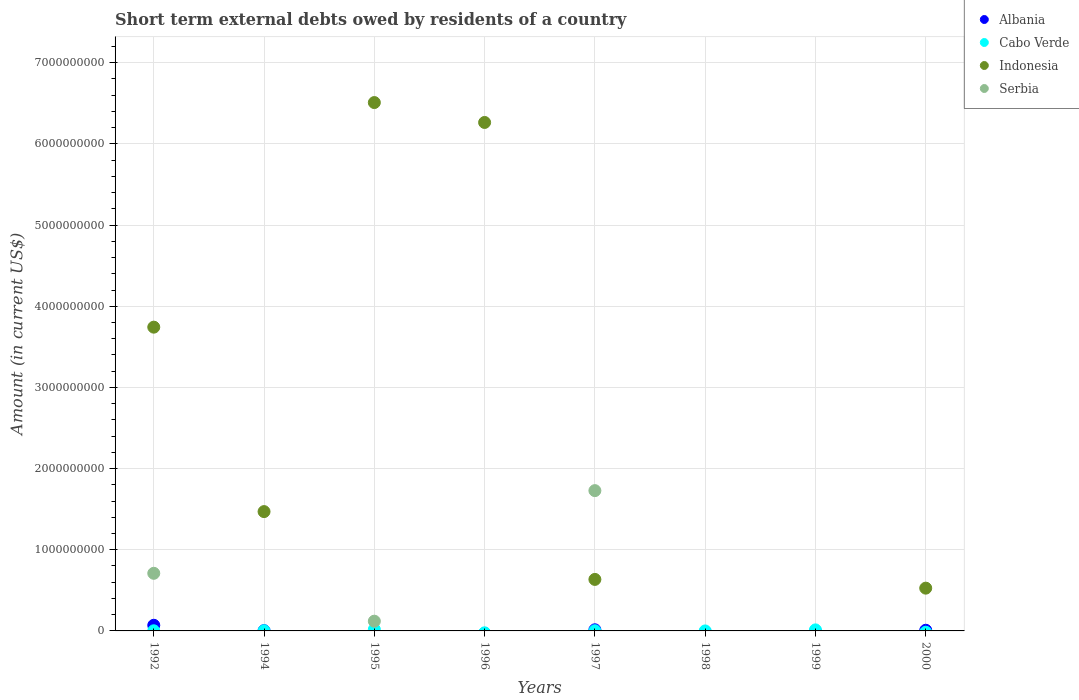How many different coloured dotlines are there?
Give a very brief answer. 4. What is the amount of short-term external debts owed by residents in Serbia in 1998?
Your response must be concise. 0. Across all years, what is the maximum amount of short-term external debts owed by residents in Cabo Verde?
Your response must be concise. 1.87e+07. What is the total amount of short-term external debts owed by residents in Serbia in the graph?
Your answer should be compact. 2.56e+09. What is the difference between the amount of short-term external debts owed by residents in Indonesia in 1996 and that in 1997?
Your answer should be very brief. 5.63e+09. What is the difference between the amount of short-term external debts owed by residents in Serbia in 1994 and the amount of short-term external debts owed by residents in Indonesia in 2000?
Provide a succinct answer. -5.27e+08. What is the average amount of short-term external debts owed by residents in Albania per year?
Offer a terse response. 1.19e+07. In the year 1994, what is the difference between the amount of short-term external debts owed by residents in Indonesia and amount of short-term external debts owed by residents in Cabo Verde?
Offer a terse response. 1.47e+09. What is the difference between the highest and the second highest amount of short-term external debts owed by residents in Albania?
Offer a very short reply. 5.57e+07. What is the difference between the highest and the lowest amount of short-term external debts owed by residents in Indonesia?
Keep it short and to the point. 6.51e+09. Is it the case that in every year, the sum of the amount of short-term external debts owed by residents in Cabo Verde and amount of short-term external debts owed by residents in Albania  is greater than the sum of amount of short-term external debts owed by residents in Serbia and amount of short-term external debts owed by residents in Indonesia?
Offer a very short reply. No. How many dotlines are there?
Your response must be concise. 4. How many years are there in the graph?
Give a very brief answer. 8. Are the values on the major ticks of Y-axis written in scientific E-notation?
Provide a short and direct response. No. Does the graph contain any zero values?
Make the answer very short. Yes. How many legend labels are there?
Offer a very short reply. 4. How are the legend labels stacked?
Provide a short and direct response. Vertical. What is the title of the graph?
Keep it short and to the point. Short term external debts owed by residents of a country. What is the label or title of the X-axis?
Keep it short and to the point. Years. What is the label or title of the Y-axis?
Your response must be concise. Amount (in current US$). What is the Amount (in current US$) of Albania in 1992?
Offer a terse response. 6.96e+07. What is the Amount (in current US$) in Cabo Verde in 1992?
Your answer should be compact. 1.60e+06. What is the Amount (in current US$) in Indonesia in 1992?
Your response must be concise. 3.74e+09. What is the Amount (in current US$) in Serbia in 1992?
Keep it short and to the point. 7.10e+08. What is the Amount (in current US$) in Albania in 1994?
Provide a succinct answer. 3.22e+06. What is the Amount (in current US$) of Cabo Verde in 1994?
Provide a succinct answer. 2.00e+06. What is the Amount (in current US$) in Indonesia in 1994?
Give a very brief answer. 1.47e+09. What is the Amount (in current US$) of Albania in 1995?
Provide a succinct answer. 0. What is the Amount (in current US$) in Cabo Verde in 1995?
Provide a short and direct response. 1.87e+07. What is the Amount (in current US$) in Indonesia in 1995?
Ensure brevity in your answer.  6.51e+09. What is the Amount (in current US$) in Serbia in 1995?
Offer a terse response. 1.20e+08. What is the Amount (in current US$) of Albania in 1996?
Offer a terse response. 0. What is the Amount (in current US$) of Cabo Verde in 1996?
Your response must be concise. 0. What is the Amount (in current US$) of Indonesia in 1996?
Provide a short and direct response. 6.26e+09. What is the Amount (in current US$) of Serbia in 1996?
Provide a short and direct response. 0. What is the Amount (in current US$) in Albania in 1997?
Keep it short and to the point. 1.39e+07. What is the Amount (in current US$) in Cabo Verde in 1997?
Provide a succinct answer. 1.96e+06. What is the Amount (in current US$) in Indonesia in 1997?
Your answer should be very brief. 6.35e+08. What is the Amount (in current US$) in Serbia in 1997?
Your answer should be compact. 1.73e+09. What is the Amount (in current US$) of Cabo Verde in 1998?
Ensure brevity in your answer.  0. What is the Amount (in current US$) in Albania in 1999?
Ensure brevity in your answer.  0. What is the Amount (in current US$) of Cabo Verde in 1999?
Keep it short and to the point. 1.28e+07. What is the Amount (in current US$) of Serbia in 1999?
Your answer should be compact. 0. What is the Amount (in current US$) of Albania in 2000?
Your response must be concise. 8.19e+06. What is the Amount (in current US$) in Indonesia in 2000?
Offer a terse response. 5.27e+08. What is the Amount (in current US$) in Serbia in 2000?
Provide a short and direct response. 0. Across all years, what is the maximum Amount (in current US$) of Albania?
Give a very brief answer. 6.96e+07. Across all years, what is the maximum Amount (in current US$) in Cabo Verde?
Your response must be concise. 1.87e+07. Across all years, what is the maximum Amount (in current US$) of Indonesia?
Give a very brief answer. 6.51e+09. Across all years, what is the maximum Amount (in current US$) in Serbia?
Your answer should be very brief. 1.73e+09. Across all years, what is the minimum Amount (in current US$) in Indonesia?
Keep it short and to the point. 0. Across all years, what is the minimum Amount (in current US$) in Serbia?
Give a very brief answer. 0. What is the total Amount (in current US$) in Albania in the graph?
Provide a short and direct response. 9.49e+07. What is the total Amount (in current US$) of Cabo Verde in the graph?
Offer a terse response. 3.70e+07. What is the total Amount (in current US$) of Indonesia in the graph?
Offer a terse response. 1.91e+1. What is the total Amount (in current US$) in Serbia in the graph?
Provide a short and direct response. 2.56e+09. What is the difference between the Amount (in current US$) in Albania in 1992 and that in 1994?
Your answer should be very brief. 6.64e+07. What is the difference between the Amount (in current US$) in Cabo Verde in 1992 and that in 1994?
Offer a terse response. -4.00e+05. What is the difference between the Amount (in current US$) of Indonesia in 1992 and that in 1994?
Keep it short and to the point. 2.27e+09. What is the difference between the Amount (in current US$) in Cabo Verde in 1992 and that in 1995?
Give a very brief answer. -1.71e+07. What is the difference between the Amount (in current US$) of Indonesia in 1992 and that in 1995?
Your answer should be compact. -2.77e+09. What is the difference between the Amount (in current US$) in Serbia in 1992 and that in 1995?
Your response must be concise. 5.90e+08. What is the difference between the Amount (in current US$) of Indonesia in 1992 and that in 1996?
Provide a short and direct response. -2.52e+09. What is the difference between the Amount (in current US$) in Albania in 1992 and that in 1997?
Give a very brief answer. 5.57e+07. What is the difference between the Amount (in current US$) of Cabo Verde in 1992 and that in 1997?
Keep it short and to the point. -3.60e+05. What is the difference between the Amount (in current US$) in Indonesia in 1992 and that in 1997?
Offer a terse response. 3.11e+09. What is the difference between the Amount (in current US$) in Serbia in 1992 and that in 1997?
Provide a succinct answer. -1.02e+09. What is the difference between the Amount (in current US$) in Cabo Verde in 1992 and that in 1999?
Offer a terse response. -1.12e+07. What is the difference between the Amount (in current US$) in Albania in 1992 and that in 2000?
Your answer should be very brief. 6.14e+07. What is the difference between the Amount (in current US$) of Indonesia in 1992 and that in 2000?
Give a very brief answer. 3.22e+09. What is the difference between the Amount (in current US$) of Cabo Verde in 1994 and that in 1995?
Provide a short and direct response. -1.67e+07. What is the difference between the Amount (in current US$) of Indonesia in 1994 and that in 1995?
Provide a succinct answer. -5.04e+09. What is the difference between the Amount (in current US$) of Indonesia in 1994 and that in 1996?
Offer a terse response. -4.79e+09. What is the difference between the Amount (in current US$) in Albania in 1994 and that in 1997?
Make the answer very short. -1.07e+07. What is the difference between the Amount (in current US$) in Cabo Verde in 1994 and that in 1997?
Provide a short and direct response. 4.00e+04. What is the difference between the Amount (in current US$) of Indonesia in 1994 and that in 1997?
Give a very brief answer. 8.35e+08. What is the difference between the Amount (in current US$) in Cabo Verde in 1994 and that in 1999?
Your response must be concise. -1.08e+07. What is the difference between the Amount (in current US$) of Albania in 1994 and that in 2000?
Give a very brief answer. -4.97e+06. What is the difference between the Amount (in current US$) in Indonesia in 1994 and that in 2000?
Provide a short and direct response. 9.43e+08. What is the difference between the Amount (in current US$) in Indonesia in 1995 and that in 1996?
Give a very brief answer. 2.45e+08. What is the difference between the Amount (in current US$) in Cabo Verde in 1995 and that in 1997?
Make the answer very short. 1.67e+07. What is the difference between the Amount (in current US$) in Indonesia in 1995 and that in 1997?
Give a very brief answer. 5.87e+09. What is the difference between the Amount (in current US$) in Serbia in 1995 and that in 1997?
Make the answer very short. -1.61e+09. What is the difference between the Amount (in current US$) of Cabo Verde in 1995 and that in 1999?
Offer a very short reply. 5.88e+06. What is the difference between the Amount (in current US$) in Indonesia in 1995 and that in 2000?
Provide a succinct answer. 5.98e+09. What is the difference between the Amount (in current US$) of Indonesia in 1996 and that in 1997?
Provide a short and direct response. 5.63e+09. What is the difference between the Amount (in current US$) of Indonesia in 1996 and that in 2000?
Keep it short and to the point. 5.74e+09. What is the difference between the Amount (in current US$) in Cabo Verde in 1997 and that in 1999?
Give a very brief answer. -1.08e+07. What is the difference between the Amount (in current US$) of Albania in 1997 and that in 2000?
Make the answer very short. 5.74e+06. What is the difference between the Amount (in current US$) in Indonesia in 1997 and that in 2000?
Offer a very short reply. 1.08e+08. What is the difference between the Amount (in current US$) of Albania in 1992 and the Amount (in current US$) of Cabo Verde in 1994?
Keep it short and to the point. 6.76e+07. What is the difference between the Amount (in current US$) of Albania in 1992 and the Amount (in current US$) of Indonesia in 1994?
Ensure brevity in your answer.  -1.40e+09. What is the difference between the Amount (in current US$) of Cabo Verde in 1992 and the Amount (in current US$) of Indonesia in 1994?
Provide a succinct answer. -1.47e+09. What is the difference between the Amount (in current US$) of Albania in 1992 and the Amount (in current US$) of Cabo Verde in 1995?
Ensure brevity in your answer.  5.09e+07. What is the difference between the Amount (in current US$) of Albania in 1992 and the Amount (in current US$) of Indonesia in 1995?
Offer a very short reply. -6.44e+09. What is the difference between the Amount (in current US$) of Albania in 1992 and the Amount (in current US$) of Serbia in 1995?
Your response must be concise. -5.03e+07. What is the difference between the Amount (in current US$) in Cabo Verde in 1992 and the Amount (in current US$) in Indonesia in 1995?
Make the answer very short. -6.51e+09. What is the difference between the Amount (in current US$) of Cabo Verde in 1992 and the Amount (in current US$) of Serbia in 1995?
Give a very brief answer. -1.18e+08. What is the difference between the Amount (in current US$) in Indonesia in 1992 and the Amount (in current US$) in Serbia in 1995?
Your response must be concise. 3.62e+09. What is the difference between the Amount (in current US$) in Albania in 1992 and the Amount (in current US$) in Indonesia in 1996?
Your answer should be very brief. -6.19e+09. What is the difference between the Amount (in current US$) of Cabo Verde in 1992 and the Amount (in current US$) of Indonesia in 1996?
Ensure brevity in your answer.  -6.26e+09. What is the difference between the Amount (in current US$) in Albania in 1992 and the Amount (in current US$) in Cabo Verde in 1997?
Offer a terse response. 6.76e+07. What is the difference between the Amount (in current US$) of Albania in 1992 and the Amount (in current US$) of Indonesia in 1997?
Offer a terse response. -5.65e+08. What is the difference between the Amount (in current US$) in Albania in 1992 and the Amount (in current US$) in Serbia in 1997?
Give a very brief answer. -1.66e+09. What is the difference between the Amount (in current US$) in Cabo Verde in 1992 and the Amount (in current US$) in Indonesia in 1997?
Give a very brief answer. -6.33e+08. What is the difference between the Amount (in current US$) in Cabo Verde in 1992 and the Amount (in current US$) in Serbia in 1997?
Make the answer very short. -1.73e+09. What is the difference between the Amount (in current US$) of Indonesia in 1992 and the Amount (in current US$) of Serbia in 1997?
Keep it short and to the point. 2.01e+09. What is the difference between the Amount (in current US$) in Albania in 1992 and the Amount (in current US$) in Cabo Verde in 1999?
Provide a succinct answer. 5.68e+07. What is the difference between the Amount (in current US$) in Albania in 1992 and the Amount (in current US$) in Indonesia in 2000?
Offer a very short reply. -4.57e+08. What is the difference between the Amount (in current US$) of Cabo Verde in 1992 and the Amount (in current US$) of Indonesia in 2000?
Your response must be concise. -5.25e+08. What is the difference between the Amount (in current US$) of Albania in 1994 and the Amount (in current US$) of Cabo Verde in 1995?
Your response must be concise. -1.54e+07. What is the difference between the Amount (in current US$) in Albania in 1994 and the Amount (in current US$) in Indonesia in 1995?
Your response must be concise. -6.51e+09. What is the difference between the Amount (in current US$) of Albania in 1994 and the Amount (in current US$) of Serbia in 1995?
Offer a very short reply. -1.17e+08. What is the difference between the Amount (in current US$) in Cabo Verde in 1994 and the Amount (in current US$) in Indonesia in 1995?
Your response must be concise. -6.51e+09. What is the difference between the Amount (in current US$) of Cabo Verde in 1994 and the Amount (in current US$) of Serbia in 1995?
Your answer should be compact. -1.18e+08. What is the difference between the Amount (in current US$) in Indonesia in 1994 and the Amount (in current US$) in Serbia in 1995?
Provide a short and direct response. 1.35e+09. What is the difference between the Amount (in current US$) of Albania in 1994 and the Amount (in current US$) of Indonesia in 1996?
Offer a terse response. -6.26e+09. What is the difference between the Amount (in current US$) in Cabo Verde in 1994 and the Amount (in current US$) in Indonesia in 1996?
Keep it short and to the point. -6.26e+09. What is the difference between the Amount (in current US$) in Albania in 1994 and the Amount (in current US$) in Cabo Verde in 1997?
Offer a very short reply. 1.26e+06. What is the difference between the Amount (in current US$) in Albania in 1994 and the Amount (in current US$) in Indonesia in 1997?
Make the answer very short. -6.31e+08. What is the difference between the Amount (in current US$) in Albania in 1994 and the Amount (in current US$) in Serbia in 1997?
Offer a very short reply. -1.73e+09. What is the difference between the Amount (in current US$) of Cabo Verde in 1994 and the Amount (in current US$) of Indonesia in 1997?
Provide a succinct answer. -6.33e+08. What is the difference between the Amount (in current US$) in Cabo Verde in 1994 and the Amount (in current US$) in Serbia in 1997?
Make the answer very short. -1.73e+09. What is the difference between the Amount (in current US$) in Indonesia in 1994 and the Amount (in current US$) in Serbia in 1997?
Your response must be concise. -2.58e+08. What is the difference between the Amount (in current US$) of Albania in 1994 and the Amount (in current US$) of Cabo Verde in 1999?
Provide a succinct answer. -9.56e+06. What is the difference between the Amount (in current US$) in Albania in 1994 and the Amount (in current US$) in Indonesia in 2000?
Your answer should be very brief. -5.24e+08. What is the difference between the Amount (in current US$) in Cabo Verde in 1994 and the Amount (in current US$) in Indonesia in 2000?
Provide a succinct answer. -5.25e+08. What is the difference between the Amount (in current US$) in Cabo Verde in 1995 and the Amount (in current US$) in Indonesia in 1996?
Provide a short and direct response. -6.25e+09. What is the difference between the Amount (in current US$) in Cabo Verde in 1995 and the Amount (in current US$) in Indonesia in 1997?
Provide a short and direct response. -6.16e+08. What is the difference between the Amount (in current US$) of Cabo Verde in 1995 and the Amount (in current US$) of Serbia in 1997?
Provide a succinct answer. -1.71e+09. What is the difference between the Amount (in current US$) of Indonesia in 1995 and the Amount (in current US$) of Serbia in 1997?
Offer a very short reply. 4.78e+09. What is the difference between the Amount (in current US$) of Cabo Verde in 1995 and the Amount (in current US$) of Indonesia in 2000?
Offer a terse response. -5.08e+08. What is the difference between the Amount (in current US$) of Indonesia in 1996 and the Amount (in current US$) of Serbia in 1997?
Your response must be concise. 4.54e+09. What is the difference between the Amount (in current US$) in Albania in 1997 and the Amount (in current US$) in Cabo Verde in 1999?
Ensure brevity in your answer.  1.15e+06. What is the difference between the Amount (in current US$) of Albania in 1997 and the Amount (in current US$) of Indonesia in 2000?
Provide a succinct answer. -5.13e+08. What is the difference between the Amount (in current US$) in Cabo Verde in 1997 and the Amount (in current US$) in Indonesia in 2000?
Give a very brief answer. -5.25e+08. What is the difference between the Amount (in current US$) of Cabo Verde in 1999 and the Amount (in current US$) of Indonesia in 2000?
Your answer should be compact. -5.14e+08. What is the average Amount (in current US$) of Albania per year?
Provide a short and direct response. 1.19e+07. What is the average Amount (in current US$) in Cabo Verde per year?
Your answer should be compact. 4.62e+06. What is the average Amount (in current US$) in Indonesia per year?
Make the answer very short. 2.39e+09. What is the average Amount (in current US$) of Serbia per year?
Keep it short and to the point. 3.20e+08. In the year 1992, what is the difference between the Amount (in current US$) in Albania and Amount (in current US$) in Cabo Verde?
Offer a very short reply. 6.80e+07. In the year 1992, what is the difference between the Amount (in current US$) of Albania and Amount (in current US$) of Indonesia?
Give a very brief answer. -3.67e+09. In the year 1992, what is the difference between the Amount (in current US$) of Albania and Amount (in current US$) of Serbia?
Offer a very short reply. -6.40e+08. In the year 1992, what is the difference between the Amount (in current US$) in Cabo Verde and Amount (in current US$) in Indonesia?
Provide a short and direct response. -3.74e+09. In the year 1992, what is the difference between the Amount (in current US$) of Cabo Verde and Amount (in current US$) of Serbia?
Your response must be concise. -7.08e+08. In the year 1992, what is the difference between the Amount (in current US$) in Indonesia and Amount (in current US$) in Serbia?
Your response must be concise. 3.03e+09. In the year 1994, what is the difference between the Amount (in current US$) in Albania and Amount (in current US$) in Cabo Verde?
Provide a short and direct response. 1.22e+06. In the year 1994, what is the difference between the Amount (in current US$) in Albania and Amount (in current US$) in Indonesia?
Make the answer very short. -1.47e+09. In the year 1994, what is the difference between the Amount (in current US$) in Cabo Verde and Amount (in current US$) in Indonesia?
Keep it short and to the point. -1.47e+09. In the year 1995, what is the difference between the Amount (in current US$) in Cabo Verde and Amount (in current US$) in Indonesia?
Give a very brief answer. -6.49e+09. In the year 1995, what is the difference between the Amount (in current US$) of Cabo Verde and Amount (in current US$) of Serbia?
Keep it short and to the point. -1.01e+08. In the year 1995, what is the difference between the Amount (in current US$) in Indonesia and Amount (in current US$) in Serbia?
Your response must be concise. 6.39e+09. In the year 1997, what is the difference between the Amount (in current US$) of Albania and Amount (in current US$) of Cabo Verde?
Keep it short and to the point. 1.20e+07. In the year 1997, what is the difference between the Amount (in current US$) of Albania and Amount (in current US$) of Indonesia?
Your response must be concise. -6.21e+08. In the year 1997, what is the difference between the Amount (in current US$) in Albania and Amount (in current US$) in Serbia?
Give a very brief answer. -1.71e+09. In the year 1997, what is the difference between the Amount (in current US$) of Cabo Verde and Amount (in current US$) of Indonesia?
Provide a short and direct response. -6.33e+08. In the year 1997, what is the difference between the Amount (in current US$) of Cabo Verde and Amount (in current US$) of Serbia?
Keep it short and to the point. -1.73e+09. In the year 1997, what is the difference between the Amount (in current US$) of Indonesia and Amount (in current US$) of Serbia?
Provide a short and direct response. -1.09e+09. In the year 2000, what is the difference between the Amount (in current US$) in Albania and Amount (in current US$) in Indonesia?
Make the answer very short. -5.19e+08. What is the ratio of the Amount (in current US$) in Albania in 1992 to that in 1994?
Your answer should be very brief. 21.63. What is the ratio of the Amount (in current US$) of Cabo Verde in 1992 to that in 1994?
Offer a very short reply. 0.8. What is the ratio of the Amount (in current US$) in Indonesia in 1992 to that in 1994?
Provide a short and direct response. 2.55. What is the ratio of the Amount (in current US$) of Cabo Verde in 1992 to that in 1995?
Offer a very short reply. 0.09. What is the ratio of the Amount (in current US$) of Indonesia in 1992 to that in 1995?
Make the answer very short. 0.57. What is the ratio of the Amount (in current US$) of Serbia in 1992 to that in 1995?
Provide a short and direct response. 5.92. What is the ratio of the Amount (in current US$) in Indonesia in 1992 to that in 1996?
Provide a short and direct response. 0.6. What is the ratio of the Amount (in current US$) in Albania in 1992 to that in 1997?
Provide a succinct answer. 5. What is the ratio of the Amount (in current US$) of Cabo Verde in 1992 to that in 1997?
Your answer should be very brief. 0.82. What is the ratio of the Amount (in current US$) in Indonesia in 1992 to that in 1997?
Provide a succinct answer. 5.9. What is the ratio of the Amount (in current US$) of Serbia in 1992 to that in 1997?
Provide a succinct answer. 0.41. What is the ratio of the Amount (in current US$) of Cabo Verde in 1992 to that in 1999?
Keep it short and to the point. 0.13. What is the ratio of the Amount (in current US$) of Albania in 1992 to that in 2000?
Give a very brief answer. 8.5. What is the ratio of the Amount (in current US$) in Indonesia in 1992 to that in 2000?
Ensure brevity in your answer.  7.1. What is the ratio of the Amount (in current US$) of Cabo Verde in 1994 to that in 1995?
Your answer should be very brief. 0.11. What is the ratio of the Amount (in current US$) of Indonesia in 1994 to that in 1995?
Give a very brief answer. 0.23. What is the ratio of the Amount (in current US$) of Indonesia in 1994 to that in 1996?
Offer a very short reply. 0.23. What is the ratio of the Amount (in current US$) in Albania in 1994 to that in 1997?
Keep it short and to the point. 0.23. What is the ratio of the Amount (in current US$) of Cabo Verde in 1994 to that in 1997?
Offer a terse response. 1.02. What is the ratio of the Amount (in current US$) of Indonesia in 1994 to that in 1997?
Your answer should be compact. 2.32. What is the ratio of the Amount (in current US$) of Cabo Verde in 1994 to that in 1999?
Your response must be concise. 0.16. What is the ratio of the Amount (in current US$) of Albania in 1994 to that in 2000?
Make the answer very short. 0.39. What is the ratio of the Amount (in current US$) of Indonesia in 1994 to that in 2000?
Ensure brevity in your answer.  2.79. What is the ratio of the Amount (in current US$) of Indonesia in 1995 to that in 1996?
Your response must be concise. 1.04. What is the ratio of the Amount (in current US$) in Cabo Verde in 1995 to that in 1997?
Offer a very short reply. 9.52. What is the ratio of the Amount (in current US$) in Indonesia in 1995 to that in 1997?
Make the answer very short. 10.26. What is the ratio of the Amount (in current US$) in Serbia in 1995 to that in 1997?
Give a very brief answer. 0.07. What is the ratio of the Amount (in current US$) of Cabo Verde in 1995 to that in 1999?
Give a very brief answer. 1.46. What is the ratio of the Amount (in current US$) of Indonesia in 1995 to that in 2000?
Your answer should be compact. 12.35. What is the ratio of the Amount (in current US$) of Indonesia in 1996 to that in 1997?
Your response must be concise. 9.87. What is the ratio of the Amount (in current US$) in Indonesia in 1996 to that in 2000?
Your answer should be very brief. 11.89. What is the ratio of the Amount (in current US$) in Cabo Verde in 1997 to that in 1999?
Provide a short and direct response. 0.15. What is the ratio of the Amount (in current US$) of Albania in 1997 to that in 2000?
Offer a very short reply. 1.7. What is the ratio of the Amount (in current US$) in Indonesia in 1997 to that in 2000?
Offer a terse response. 1.2. What is the difference between the highest and the second highest Amount (in current US$) of Albania?
Your response must be concise. 5.57e+07. What is the difference between the highest and the second highest Amount (in current US$) of Cabo Verde?
Your response must be concise. 5.88e+06. What is the difference between the highest and the second highest Amount (in current US$) in Indonesia?
Keep it short and to the point. 2.45e+08. What is the difference between the highest and the second highest Amount (in current US$) in Serbia?
Offer a terse response. 1.02e+09. What is the difference between the highest and the lowest Amount (in current US$) of Albania?
Offer a terse response. 6.96e+07. What is the difference between the highest and the lowest Amount (in current US$) in Cabo Verde?
Provide a succinct answer. 1.87e+07. What is the difference between the highest and the lowest Amount (in current US$) in Indonesia?
Give a very brief answer. 6.51e+09. What is the difference between the highest and the lowest Amount (in current US$) of Serbia?
Your answer should be very brief. 1.73e+09. 